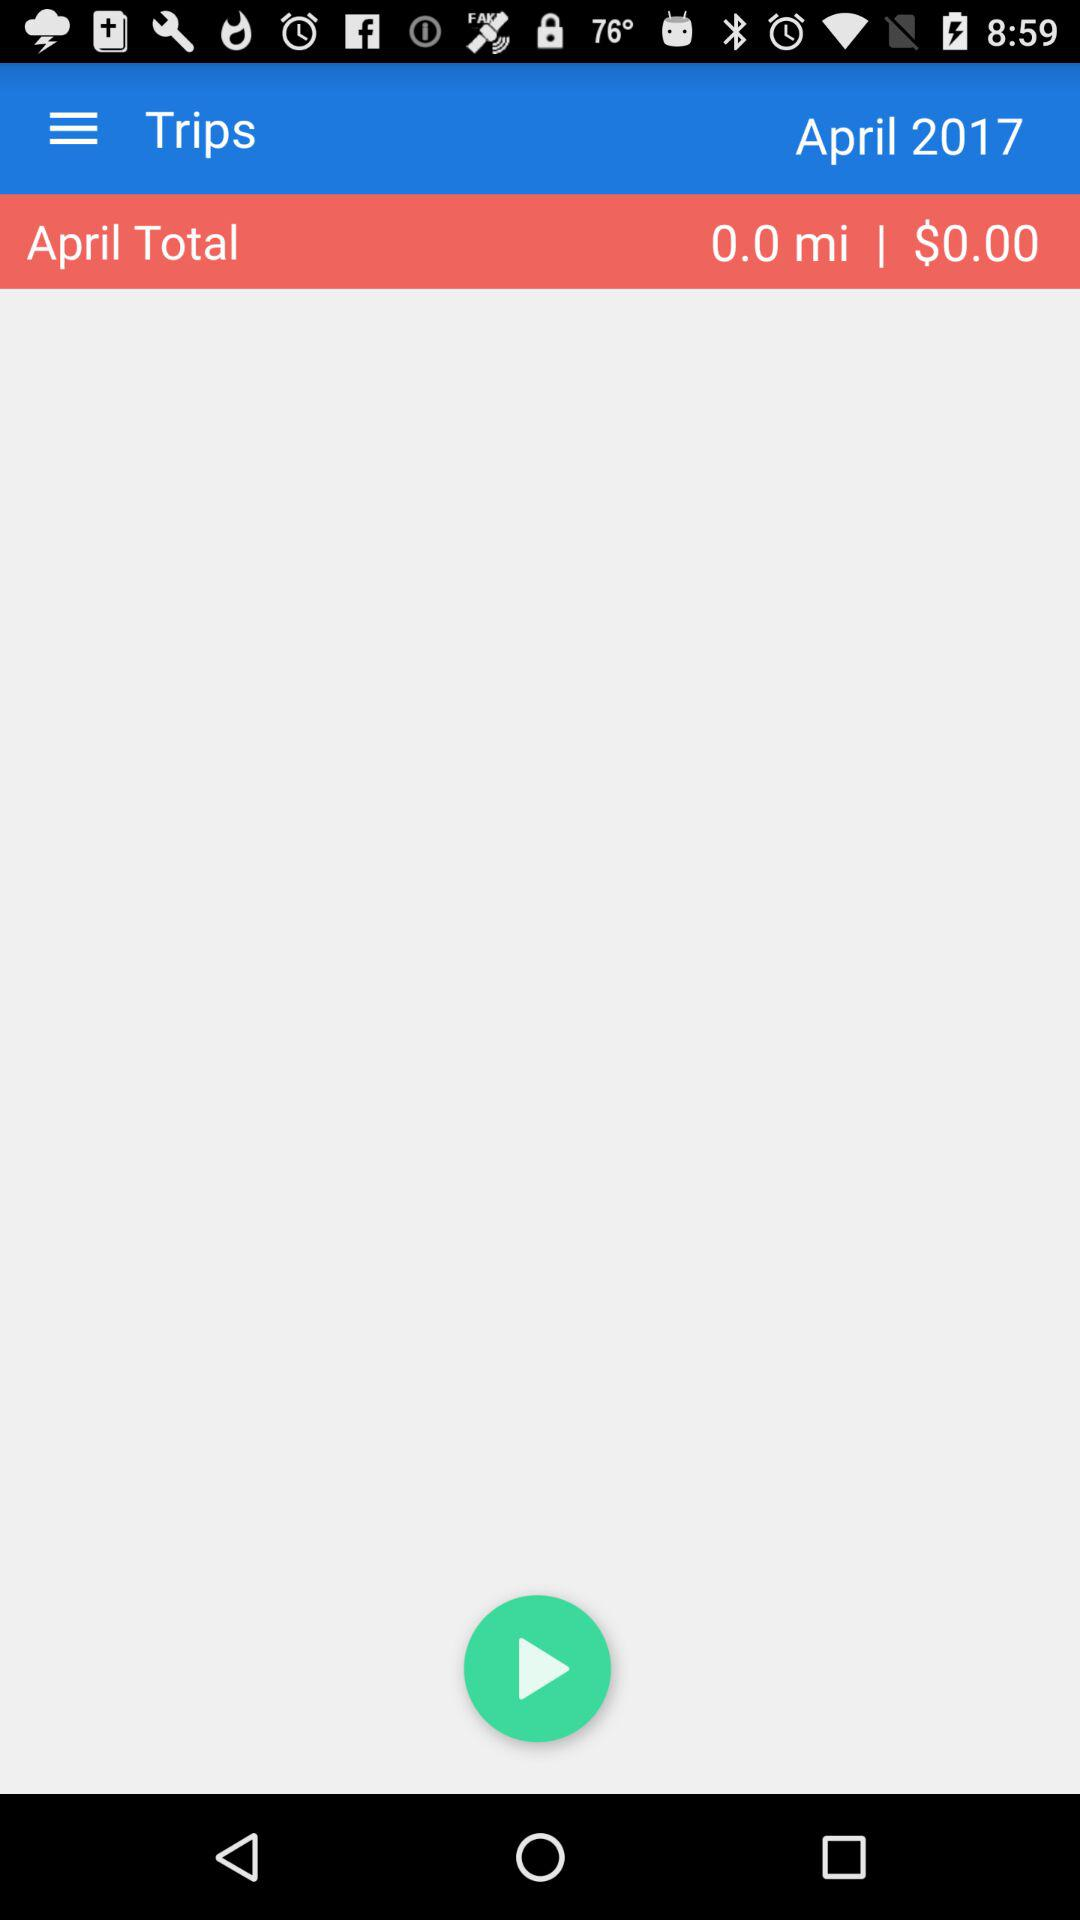How much money did I spend in April?
Answer the question using a single word or phrase. $0.00 